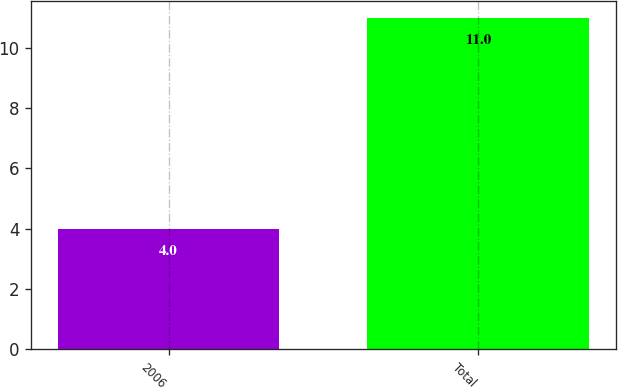Convert chart. <chart><loc_0><loc_0><loc_500><loc_500><bar_chart><fcel>2006<fcel>Total<nl><fcel>4<fcel>11<nl></chart> 